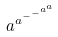Convert formula to latex. <formula><loc_0><loc_0><loc_500><loc_500>a ^ { a ^ { - ^ { - ^ { a ^ { a } } } } }</formula> 